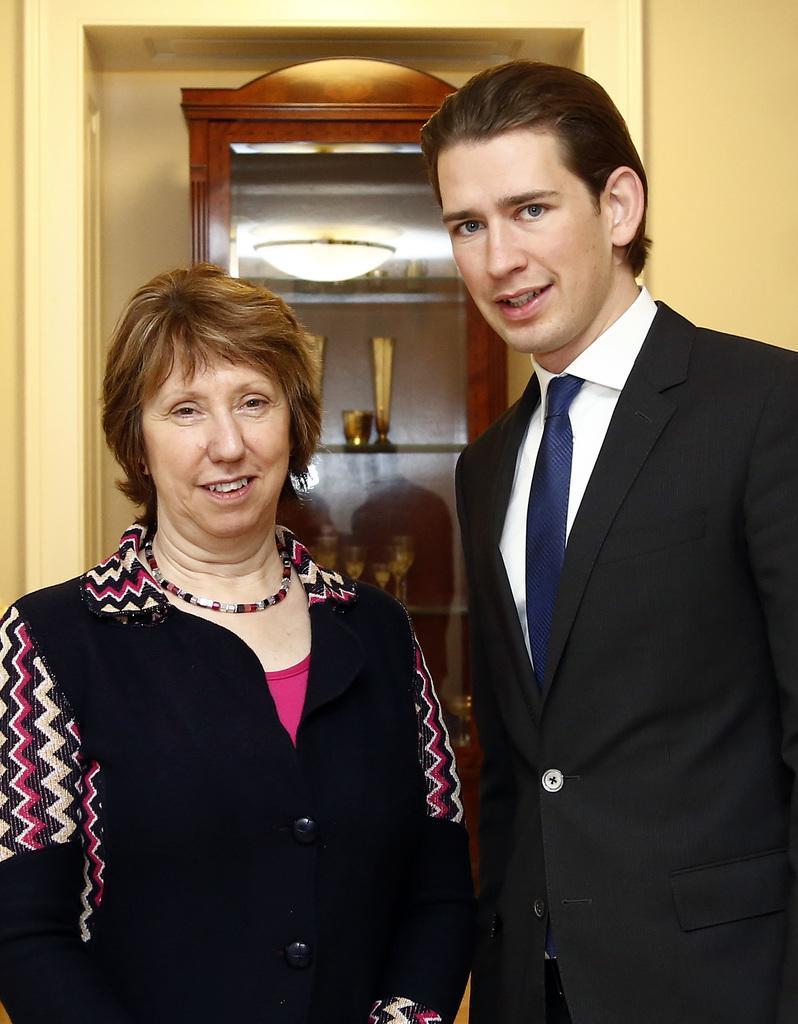How would you summarize this image in a sentence or two? In this picture there are two people standing. At the back there are glasses and objects in the cupboard and there is a reflection of light on the mirror. 